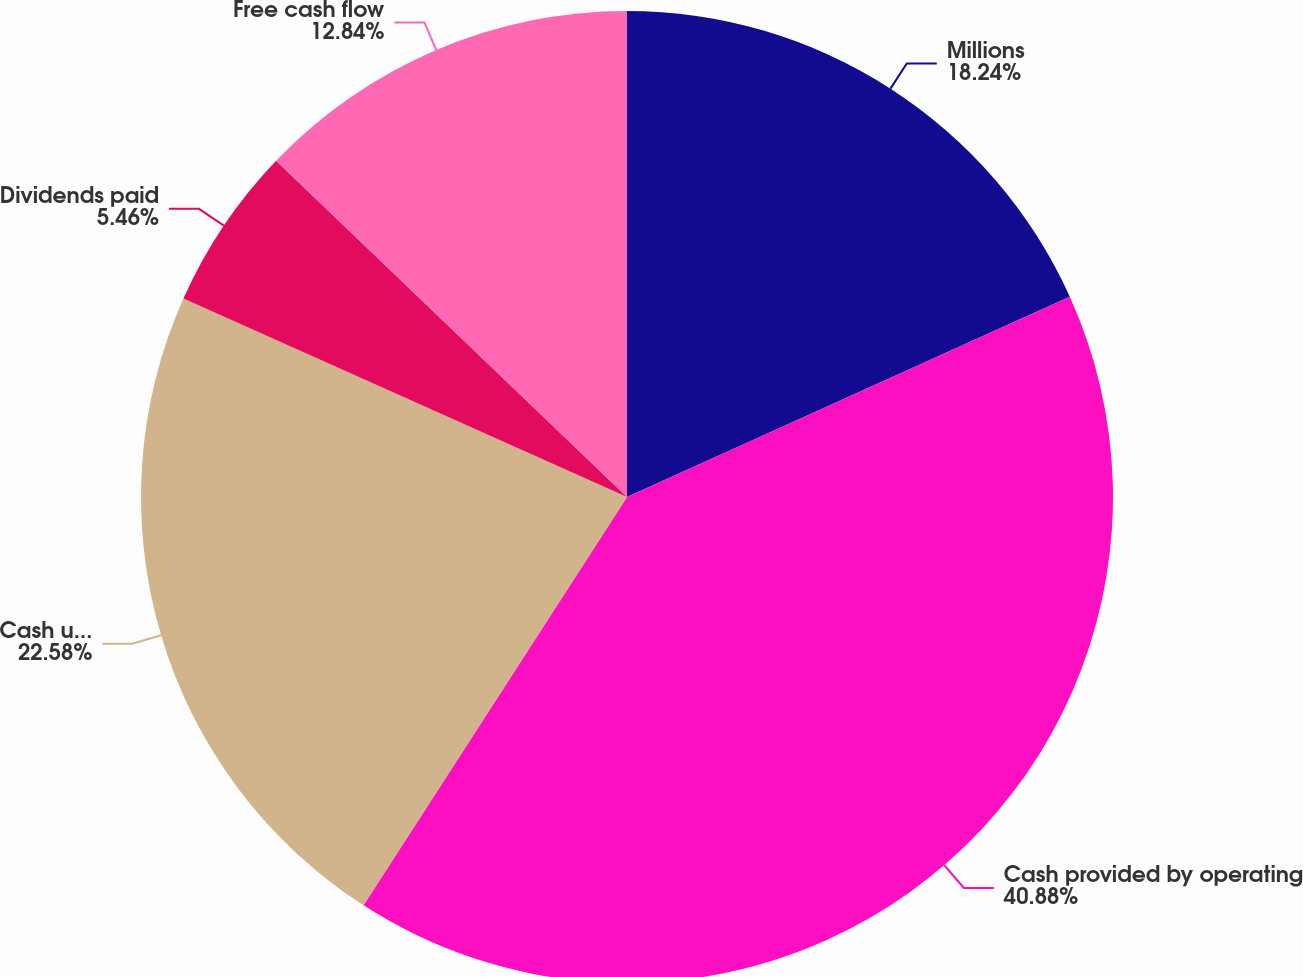<chart> <loc_0><loc_0><loc_500><loc_500><pie_chart><fcel>Millions<fcel>Cash provided by operating<fcel>Cash used in investing<fcel>Dividends paid<fcel>Free cash flow<nl><fcel>18.24%<fcel>40.88%<fcel>22.58%<fcel>5.46%<fcel>12.84%<nl></chart> 